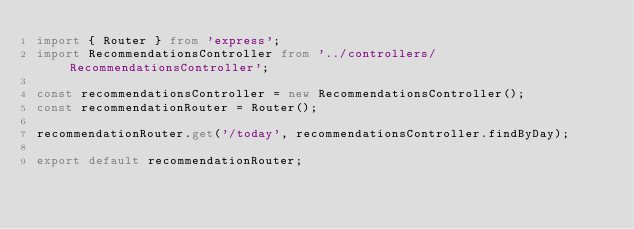<code> <loc_0><loc_0><loc_500><loc_500><_TypeScript_>import { Router } from 'express';
import RecommendationsController from '../controllers/RecommendationsController';

const recommendationsController = new RecommendationsController();
const recommendationRouter = Router();

recommendationRouter.get('/today', recommendationsController.findByDay);

export default recommendationRouter;</code> 